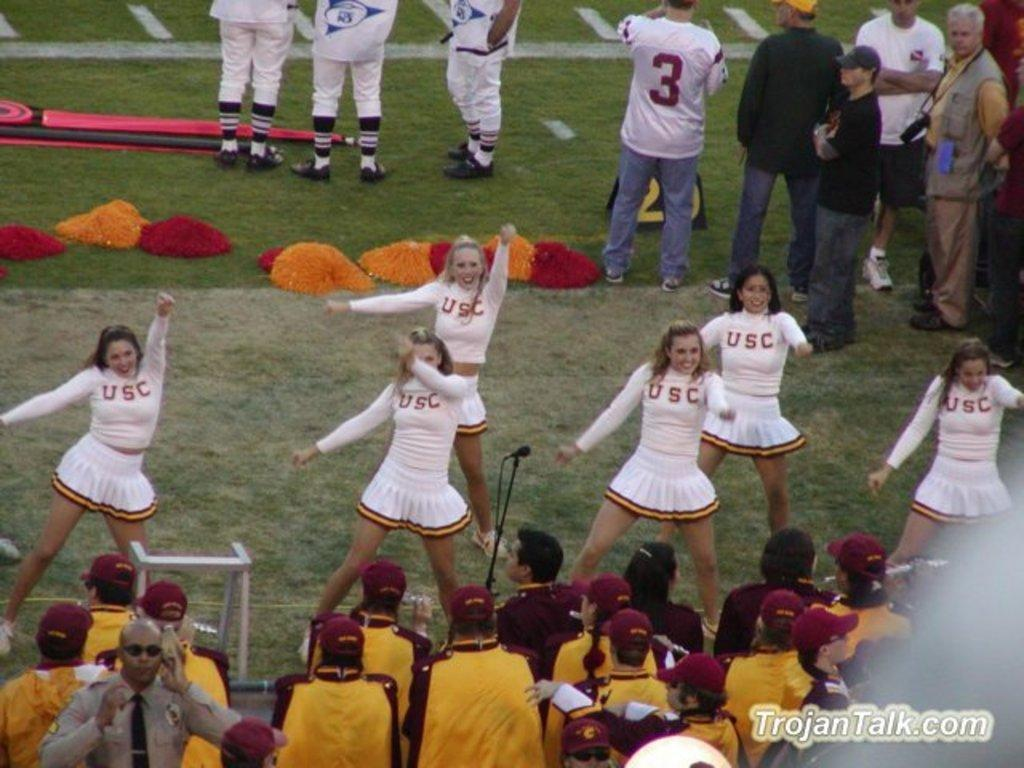<image>
Present a compact description of the photo's key features. some cheerleaders with a tojan talk logo on the right 